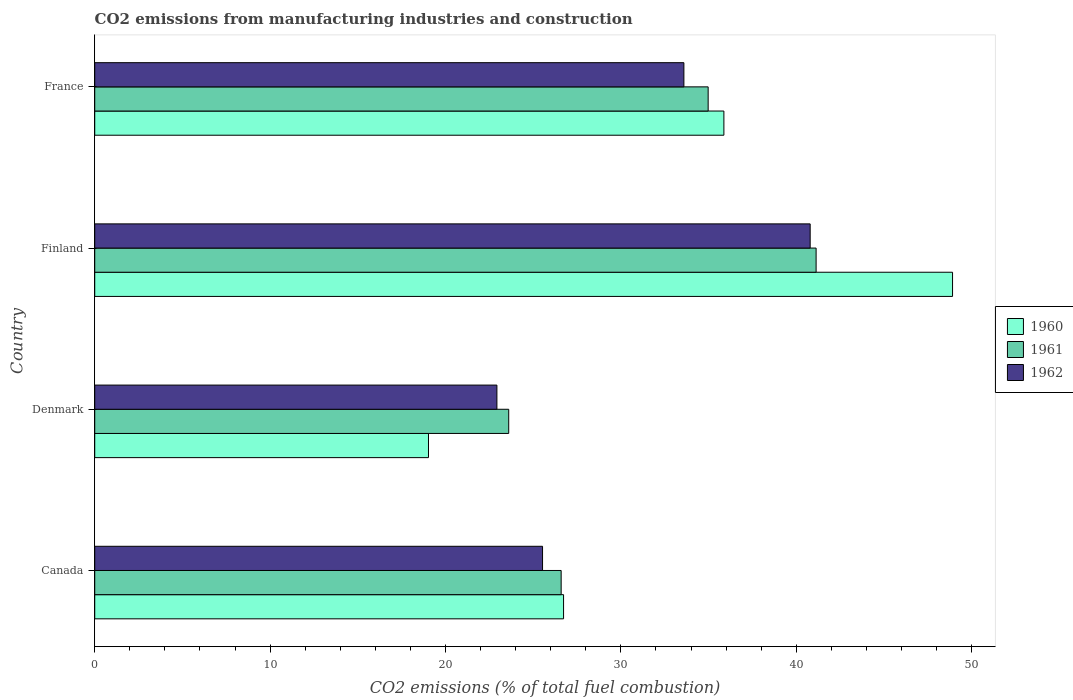How many different coloured bars are there?
Your answer should be compact. 3. How many groups of bars are there?
Ensure brevity in your answer.  4. Are the number of bars on each tick of the Y-axis equal?
Give a very brief answer. Yes. How many bars are there on the 4th tick from the bottom?
Offer a very short reply. 3. In how many cases, is the number of bars for a given country not equal to the number of legend labels?
Keep it short and to the point. 0. What is the amount of CO2 emitted in 1962 in Denmark?
Your answer should be compact. 22.93. Across all countries, what is the maximum amount of CO2 emitted in 1961?
Provide a succinct answer. 41.13. Across all countries, what is the minimum amount of CO2 emitted in 1962?
Your answer should be very brief. 22.93. What is the total amount of CO2 emitted in 1960 in the graph?
Offer a very short reply. 130.54. What is the difference between the amount of CO2 emitted in 1960 in Canada and that in Denmark?
Provide a short and direct response. 7.7. What is the difference between the amount of CO2 emitted in 1961 in Canada and the amount of CO2 emitted in 1962 in Finland?
Provide a succinct answer. -14.2. What is the average amount of CO2 emitted in 1962 per country?
Your answer should be compact. 30.71. What is the difference between the amount of CO2 emitted in 1962 and amount of CO2 emitted in 1960 in France?
Your answer should be compact. -2.28. In how many countries, is the amount of CO2 emitted in 1962 greater than 22 %?
Ensure brevity in your answer.  4. What is the ratio of the amount of CO2 emitted in 1961 in Canada to that in Denmark?
Make the answer very short. 1.13. Is the difference between the amount of CO2 emitted in 1962 in Canada and France greater than the difference between the amount of CO2 emitted in 1960 in Canada and France?
Your response must be concise. Yes. What is the difference between the highest and the second highest amount of CO2 emitted in 1960?
Your answer should be very brief. 13.04. What is the difference between the highest and the lowest amount of CO2 emitted in 1961?
Your answer should be compact. 17.53. In how many countries, is the amount of CO2 emitted in 1960 greater than the average amount of CO2 emitted in 1960 taken over all countries?
Your answer should be very brief. 2. What does the 2nd bar from the top in Denmark represents?
Offer a very short reply. 1961. How many countries are there in the graph?
Keep it short and to the point. 4. Where does the legend appear in the graph?
Offer a terse response. Center right. How many legend labels are there?
Offer a very short reply. 3. What is the title of the graph?
Offer a very short reply. CO2 emissions from manufacturing industries and construction. What is the label or title of the X-axis?
Your answer should be very brief. CO2 emissions (% of total fuel combustion). What is the label or title of the Y-axis?
Make the answer very short. Country. What is the CO2 emissions (% of total fuel combustion) of 1960 in Canada?
Give a very brief answer. 26.73. What is the CO2 emissions (% of total fuel combustion) of 1961 in Canada?
Provide a succinct answer. 26.59. What is the CO2 emissions (% of total fuel combustion) of 1962 in Canada?
Give a very brief answer. 25.53. What is the CO2 emissions (% of total fuel combustion) of 1960 in Denmark?
Offer a very short reply. 19.03. What is the CO2 emissions (% of total fuel combustion) of 1961 in Denmark?
Keep it short and to the point. 23.6. What is the CO2 emissions (% of total fuel combustion) of 1962 in Denmark?
Ensure brevity in your answer.  22.93. What is the CO2 emissions (% of total fuel combustion) of 1960 in Finland?
Provide a succinct answer. 48.91. What is the CO2 emissions (% of total fuel combustion) of 1961 in Finland?
Make the answer very short. 41.13. What is the CO2 emissions (% of total fuel combustion) of 1962 in Finland?
Provide a succinct answer. 40.79. What is the CO2 emissions (% of total fuel combustion) of 1960 in France?
Your answer should be very brief. 35.87. What is the CO2 emissions (% of total fuel combustion) in 1961 in France?
Your answer should be very brief. 34.98. What is the CO2 emissions (% of total fuel combustion) in 1962 in France?
Provide a succinct answer. 33.59. Across all countries, what is the maximum CO2 emissions (% of total fuel combustion) of 1960?
Provide a succinct answer. 48.91. Across all countries, what is the maximum CO2 emissions (% of total fuel combustion) in 1961?
Offer a terse response. 41.13. Across all countries, what is the maximum CO2 emissions (% of total fuel combustion) in 1962?
Your answer should be very brief. 40.79. Across all countries, what is the minimum CO2 emissions (% of total fuel combustion) in 1960?
Give a very brief answer. 19.03. Across all countries, what is the minimum CO2 emissions (% of total fuel combustion) of 1961?
Give a very brief answer. 23.6. Across all countries, what is the minimum CO2 emissions (% of total fuel combustion) in 1962?
Make the answer very short. 22.93. What is the total CO2 emissions (% of total fuel combustion) of 1960 in the graph?
Give a very brief answer. 130.54. What is the total CO2 emissions (% of total fuel combustion) of 1961 in the graph?
Your answer should be compact. 126.3. What is the total CO2 emissions (% of total fuel combustion) of 1962 in the graph?
Provide a short and direct response. 122.85. What is the difference between the CO2 emissions (% of total fuel combustion) in 1960 in Canada and that in Denmark?
Make the answer very short. 7.7. What is the difference between the CO2 emissions (% of total fuel combustion) in 1961 in Canada and that in Denmark?
Offer a very short reply. 2.99. What is the difference between the CO2 emissions (% of total fuel combustion) of 1962 in Canada and that in Denmark?
Your answer should be very brief. 2.6. What is the difference between the CO2 emissions (% of total fuel combustion) in 1960 in Canada and that in Finland?
Ensure brevity in your answer.  -22.18. What is the difference between the CO2 emissions (% of total fuel combustion) of 1961 in Canada and that in Finland?
Offer a very short reply. -14.54. What is the difference between the CO2 emissions (% of total fuel combustion) of 1962 in Canada and that in Finland?
Keep it short and to the point. -15.26. What is the difference between the CO2 emissions (% of total fuel combustion) in 1960 in Canada and that in France?
Keep it short and to the point. -9.14. What is the difference between the CO2 emissions (% of total fuel combustion) of 1961 in Canada and that in France?
Provide a short and direct response. -8.38. What is the difference between the CO2 emissions (% of total fuel combustion) in 1962 in Canada and that in France?
Your answer should be very brief. -8.06. What is the difference between the CO2 emissions (% of total fuel combustion) in 1960 in Denmark and that in Finland?
Give a very brief answer. -29.88. What is the difference between the CO2 emissions (% of total fuel combustion) in 1961 in Denmark and that in Finland?
Your answer should be very brief. -17.53. What is the difference between the CO2 emissions (% of total fuel combustion) in 1962 in Denmark and that in Finland?
Your answer should be compact. -17.86. What is the difference between the CO2 emissions (% of total fuel combustion) in 1960 in Denmark and that in France?
Give a very brief answer. -16.84. What is the difference between the CO2 emissions (% of total fuel combustion) in 1961 in Denmark and that in France?
Offer a terse response. -11.37. What is the difference between the CO2 emissions (% of total fuel combustion) in 1962 in Denmark and that in France?
Provide a short and direct response. -10.66. What is the difference between the CO2 emissions (% of total fuel combustion) in 1960 in Finland and that in France?
Offer a very short reply. 13.04. What is the difference between the CO2 emissions (% of total fuel combustion) of 1961 in Finland and that in France?
Keep it short and to the point. 6.16. What is the difference between the CO2 emissions (% of total fuel combustion) of 1962 in Finland and that in France?
Your answer should be compact. 7.2. What is the difference between the CO2 emissions (% of total fuel combustion) of 1960 in Canada and the CO2 emissions (% of total fuel combustion) of 1961 in Denmark?
Your answer should be very brief. 3.13. What is the difference between the CO2 emissions (% of total fuel combustion) of 1960 in Canada and the CO2 emissions (% of total fuel combustion) of 1962 in Denmark?
Ensure brevity in your answer.  3.8. What is the difference between the CO2 emissions (% of total fuel combustion) in 1961 in Canada and the CO2 emissions (% of total fuel combustion) in 1962 in Denmark?
Your response must be concise. 3.66. What is the difference between the CO2 emissions (% of total fuel combustion) in 1960 in Canada and the CO2 emissions (% of total fuel combustion) in 1961 in Finland?
Give a very brief answer. -14.4. What is the difference between the CO2 emissions (% of total fuel combustion) in 1960 in Canada and the CO2 emissions (% of total fuel combustion) in 1962 in Finland?
Offer a very short reply. -14.06. What is the difference between the CO2 emissions (% of total fuel combustion) in 1961 in Canada and the CO2 emissions (% of total fuel combustion) in 1962 in Finland?
Offer a very short reply. -14.2. What is the difference between the CO2 emissions (% of total fuel combustion) in 1960 in Canada and the CO2 emissions (% of total fuel combustion) in 1961 in France?
Make the answer very short. -8.24. What is the difference between the CO2 emissions (% of total fuel combustion) of 1960 in Canada and the CO2 emissions (% of total fuel combustion) of 1962 in France?
Offer a terse response. -6.86. What is the difference between the CO2 emissions (% of total fuel combustion) of 1961 in Canada and the CO2 emissions (% of total fuel combustion) of 1962 in France?
Give a very brief answer. -7. What is the difference between the CO2 emissions (% of total fuel combustion) in 1960 in Denmark and the CO2 emissions (% of total fuel combustion) in 1961 in Finland?
Your response must be concise. -22.1. What is the difference between the CO2 emissions (% of total fuel combustion) of 1960 in Denmark and the CO2 emissions (% of total fuel combustion) of 1962 in Finland?
Keep it short and to the point. -21.76. What is the difference between the CO2 emissions (% of total fuel combustion) in 1961 in Denmark and the CO2 emissions (% of total fuel combustion) in 1962 in Finland?
Your answer should be compact. -17.19. What is the difference between the CO2 emissions (% of total fuel combustion) of 1960 in Denmark and the CO2 emissions (% of total fuel combustion) of 1961 in France?
Provide a short and direct response. -15.95. What is the difference between the CO2 emissions (% of total fuel combustion) in 1960 in Denmark and the CO2 emissions (% of total fuel combustion) in 1962 in France?
Make the answer very short. -14.56. What is the difference between the CO2 emissions (% of total fuel combustion) of 1961 in Denmark and the CO2 emissions (% of total fuel combustion) of 1962 in France?
Ensure brevity in your answer.  -9.99. What is the difference between the CO2 emissions (% of total fuel combustion) in 1960 in Finland and the CO2 emissions (% of total fuel combustion) in 1961 in France?
Offer a very short reply. 13.93. What is the difference between the CO2 emissions (% of total fuel combustion) in 1960 in Finland and the CO2 emissions (% of total fuel combustion) in 1962 in France?
Keep it short and to the point. 15.32. What is the difference between the CO2 emissions (% of total fuel combustion) in 1961 in Finland and the CO2 emissions (% of total fuel combustion) in 1962 in France?
Offer a very short reply. 7.54. What is the average CO2 emissions (% of total fuel combustion) in 1960 per country?
Keep it short and to the point. 32.64. What is the average CO2 emissions (% of total fuel combustion) in 1961 per country?
Keep it short and to the point. 31.58. What is the average CO2 emissions (% of total fuel combustion) of 1962 per country?
Your answer should be compact. 30.71. What is the difference between the CO2 emissions (% of total fuel combustion) of 1960 and CO2 emissions (% of total fuel combustion) of 1961 in Canada?
Your answer should be very brief. 0.14. What is the difference between the CO2 emissions (% of total fuel combustion) in 1960 and CO2 emissions (% of total fuel combustion) in 1962 in Canada?
Offer a terse response. 1.2. What is the difference between the CO2 emissions (% of total fuel combustion) in 1961 and CO2 emissions (% of total fuel combustion) in 1962 in Canada?
Give a very brief answer. 1.06. What is the difference between the CO2 emissions (% of total fuel combustion) of 1960 and CO2 emissions (% of total fuel combustion) of 1961 in Denmark?
Provide a short and direct response. -4.57. What is the difference between the CO2 emissions (% of total fuel combustion) of 1960 and CO2 emissions (% of total fuel combustion) of 1962 in Denmark?
Give a very brief answer. -3.9. What is the difference between the CO2 emissions (% of total fuel combustion) of 1961 and CO2 emissions (% of total fuel combustion) of 1962 in Denmark?
Make the answer very short. 0.67. What is the difference between the CO2 emissions (% of total fuel combustion) in 1960 and CO2 emissions (% of total fuel combustion) in 1961 in Finland?
Your answer should be very brief. 7.78. What is the difference between the CO2 emissions (% of total fuel combustion) of 1960 and CO2 emissions (% of total fuel combustion) of 1962 in Finland?
Offer a very short reply. 8.12. What is the difference between the CO2 emissions (% of total fuel combustion) in 1961 and CO2 emissions (% of total fuel combustion) in 1962 in Finland?
Give a very brief answer. 0.34. What is the difference between the CO2 emissions (% of total fuel combustion) in 1960 and CO2 emissions (% of total fuel combustion) in 1961 in France?
Make the answer very short. 0.9. What is the difference between the CO2 emissions (% of total fuel combustion) of 1960 and CO2 emissions (% of total fuel combustion) of 1962 in France?
Ensure brevity in your answer.  2.28. What is the difference between the CO2 emissions (% of total fuel combustion) in 1961 and CO2 emissions (% of total fuel combustion) in 1962 in France?
Provide a succinct answer. 1.38. What is the ratio of the CO2 emissions (% of total fuel combustion) of 1960 in Canada to that in Denmark?
Keep it short and to the point. 1.4. What is the ratio of the CO2 emissions (% of total fuel combustion) of 1961 in Canada to that in Denmark?
Provide a short and direct response. 1.13. What is the ratio of the CO2 emissions (% of total fuel combustion) of 1962 in Canada to that in Denmark?
Make the answer very short. 1.11. What is the ratio of the CO2 emissions (% of total fuel combustion) in 1960 in Canada to that in Finland?
Provide a short and direct response. 0.55. What is the ratio of the CO2 emissions (% of total fuel combustion) in 1961 in Canada to that in Finland?
Offer a very short reply. 0.65. What is the ratio of the CO2 emissions (% of total fuel combustion) of 1962 in Canada to that in Finland?
Provide a short and direct response. 0.63. What is the ratio of the CO2 emissions (% of total fuel combustion) of 1960 in Canada to that in France?
Keep it short and to the point. 0.75. What is the ratio of the CO2 emissions (% of total fuel combustion) of 1961 in Canada to that in France?
Your answer should be very brief. 0.76. What is the ratio of the CO2 emissions (% of total fuel combustion) in 1962 in Canada to that in France?
Keep it short and to the point. 0.76. What is the ratio of the CO2 emissions (% of total fuel combustion) in 1960 in Denmark to that in Finland?
Provide a short and direct response. 0.39. What is the ratio of the CO2 emissions (% of total fuel combustion) of 1961 in Denmark to that in Finland?
Your response must be concise. 0.57. What is the ratio of the CO2 emissions (% of total fuel combustion) in 1962 in Denmark to that in Finland?
Your answer should be compact. 0.56. What is the ratio of the CO2 emissions (% of total fuel combustion) in 1960 in Denmark to that in France?
Offer a very short reply. 0.53. What is the ratio of the CO2 emissions (% of total fuel combustion) of 1961 in Denmark to that in France?
Your answer should be compact. 0.67. What is the ratio of the CO2 emissions (% of total fuel combustion) of 1962 in Denmark to that in France?
Your answer should be compact. 0.68. What is the ratio of the CO2 emissions (% of total fuel combustion) of 1960 in Finland to that in France?
Offer a terse response. 1.36. What is the ratio of the CO2 emissions (% of total fuel combustion) of 1961 in Finland to that in France?
Offer a terse response. 1.18. What is the ratio of the CO2 emissions (% of total fuel combustion) in 1962 in Finland to that in France?
Your answer should be very brief. 1.21. What is the difference between the highest and the second highest CO2 emissions (% of total fuel combustion) of 1960?
Give a very brief answer. 13.04. What is the difference between the highest and the second highest CO2 emissions (% of total fuel combustion) in 1961?
Your answer should be compact. 6.16. What is the difference between the highest and the second highest CO2 emissions (% of total fuel combustion) in 1962?
Give a very brief answer. 7.2. What is the difference between the highest and the lowest CO2 emissions (% of total fuel combustion) of 1960?
Your answer should be compact. 29.88. What is the difference between the highest and the lowest CO2 emissions (% of total fuel combustion) of 1961?
Your response must be concise. 17.53. What is the difference between the highest and the lowest CO2 emissions (% of total fuel combustion) of 1962?
Ensure brevity in your answer.  17.86. 